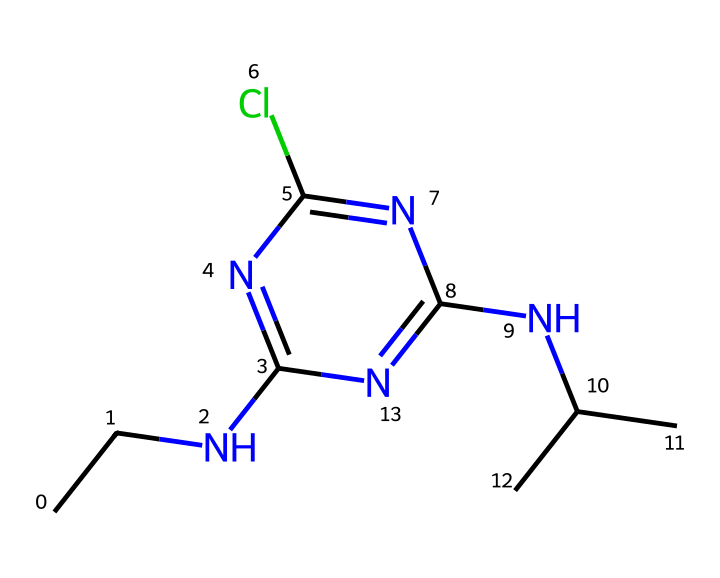How many nitrogen atoms are present in the structure of atrazine? By analyzing the SMILES representation, we can identify that there are three nitrogen atoms (N) in the structure where 'N' appears three times within the notation.
Answer: three What is the primary functional group present in atrazine? The primary functional group in atrazine is amine, as indicated by the presence of nitrogen atoms (N) bonded to alkyl groups (CC and NC(C)C). The 'N' connected to carbon chains represents the amine group.
Answer: amine How many chlorine atoms are there in atrazine? Looking at the SMILES representation, we can see there is one chlorine atom (Cl) within the structure, denoted by the 'Cl' in the notation.
Answer: one Which part of the atrazine structure contributes to its herbicidal activity? The presence of the triazine ring system (c1nc...n1) is crucial for the herbicidal activity, as this specific arrangement of nitrogen and carbon atoms is often associated with the activity of triazine-based herbicides.
Answer: triazine ring Is atrazine a polar or nonpolar molecule? The presence of multiple nitrogen and chlorine atoms suggests polarity due to the electronegative elements. This indicates that atrazine is a polar molecule because the distribution of electrons is uneven.
Answer: polar What is the degree of saturation of atrazine? To assess the degree of saturation, we find that the presence of multiple double bonds or rings can imply unsaturation, but in this case, the structure mainly consists of single bonds with a ring, indicating a saturated compound. Based on this arrangement, atrazine has little to no unsaturation.
Answer: saturated 